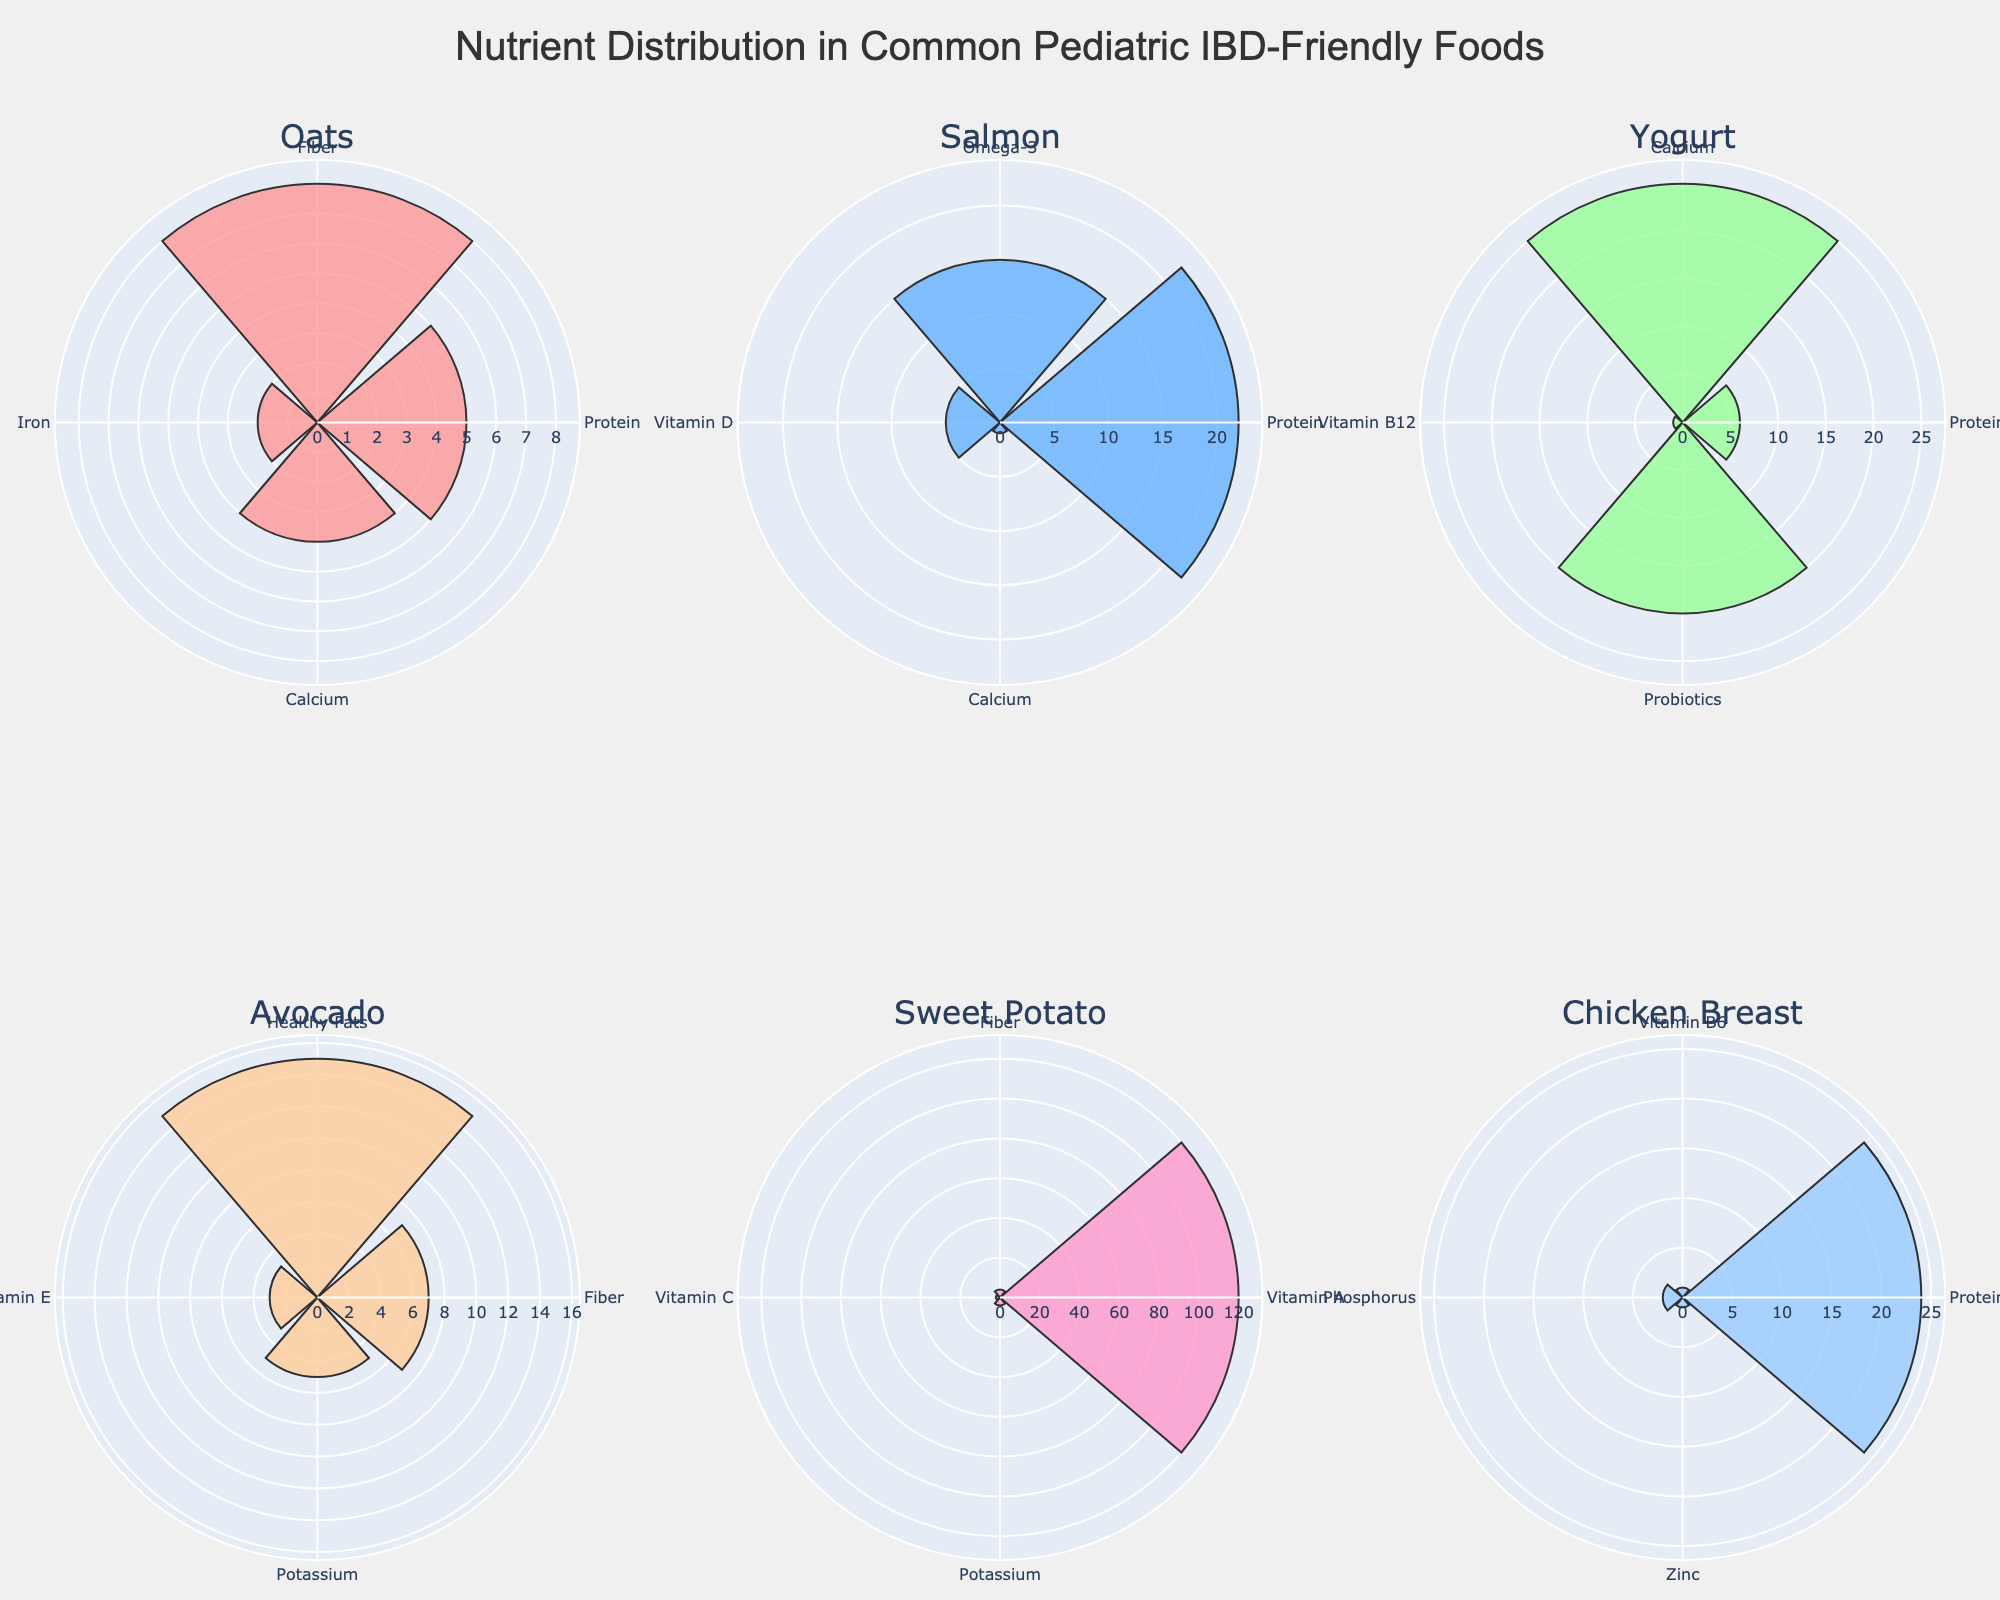What food has the highest Protein value? By examining the polar rose charts for each food, we see that Chicken Breast has the longest bar in the Protein section.
Answer: Chicken Breast Which food has the most nutrients related to Omega-3? Salmon is the only food listed with Omega-3 nutrient, and it has a bar for Omega-3 in its polar rose chart.
Answer: Salmon What's the total Fiber value combining Oats, Avocado, and Sweet Potato? Summing the Fiber values from Oats (8), Avocado (7), and Sweet Potato (4) gives us 8 + 7 + 4 = 19.
Answer: 19 Which food offers the highest Vitamin A value, and what is that value? By looking at the Vitamin A sections, Sweet Potato has the longest bar with a value of 120.
Answer: Sweet Potato, 120 Compare the Calcium value in Oats and Yogurt. Which one is higher? The Calcium value for Oats is 4, and for Yogurt, it is 25, so Yogurt has a higher Calcium value.
Answer: Yogurt How many foods show values for Potassium? Both Avocado and Sweet Potato have a bar labeled Potassium in their respective polar rose charts.
Answer: 2 What is the common nutrient between Salmon and Chicken Breast, and what are their respective values? Both foods list Protein as a nutrient. Salmon has 22, and Chicken Breast has 24 for Protein.
Answer: Protein, Salmon: 22, Chicken Breast: 24 Which food has the highest single nutrient value, and what is that nutrient? Sweet Potato has the highest single nutrient value at 120 for Vitamin A.
Answer: Sweet Potato, Vitamin A Calculate the average Protein value across all foods shown. Sum of Protein values: Oats (5) + Salmon (22) + Yogurt (6) + Chicken Breast (24) = 5 + 22 + 6 + 24 = 57. There are 4 foods with Protein, so the average is 57 / 4 = 14.25.
Answer: 14.25 Between Avocado and Yogurt, which one has a higher total nutrient value? Sum of Avocado's nutrient values: 7 (Fiber) + 15 (Healthy Fats) + 3 (Vitamin E) + 5 (Potassium) = 30. Sum of Yogurt's nutrient values: 6 (Protein) + 25 (Calcium) + 1 (Vitamin B12) + 20 (Probiotics) = 52. Yogurt has a higher total nutrient value.
Answer: Yogurt 